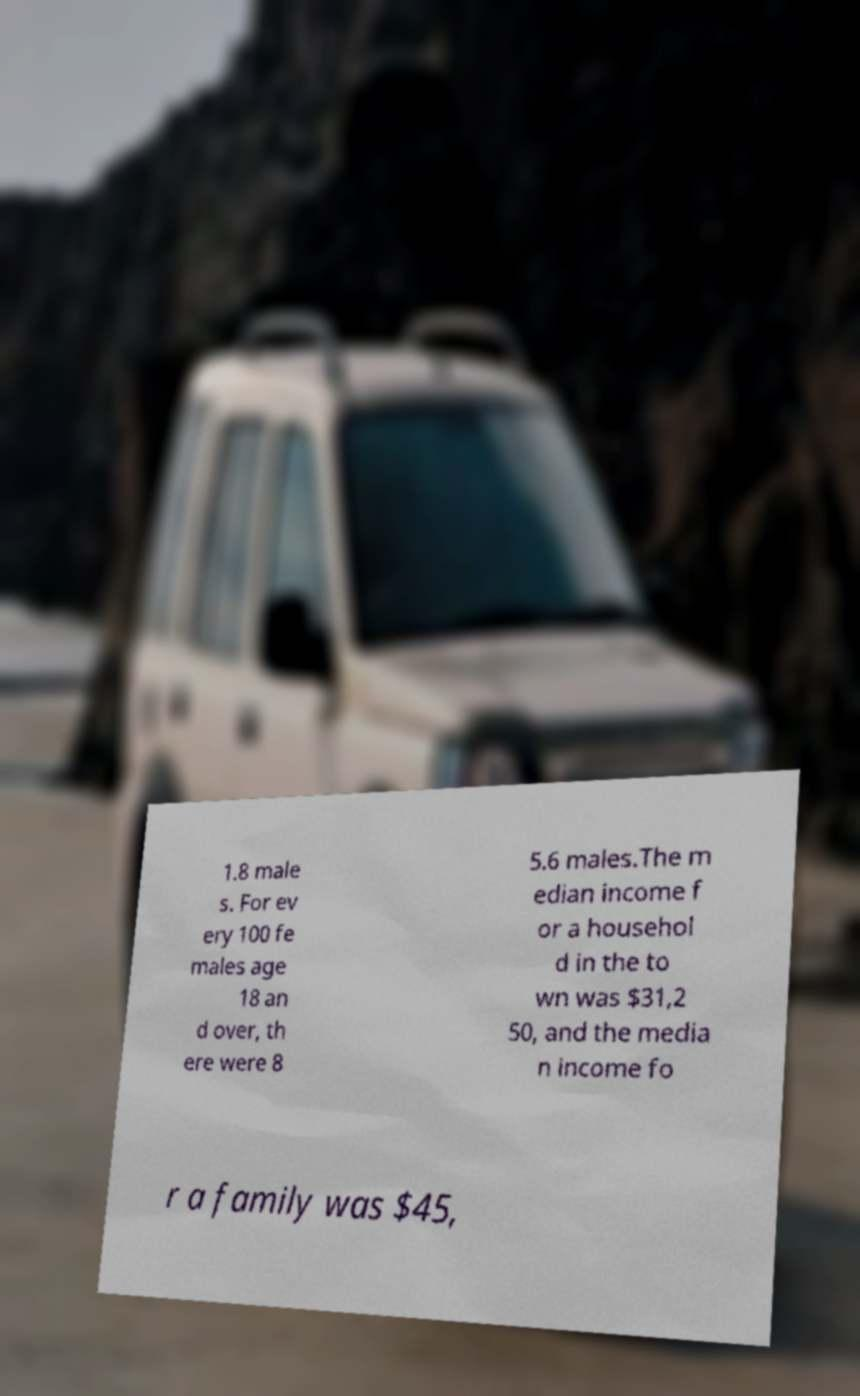There's text embedded in this image that I need extracted. Can you transcribe it verbatim? 1.8 male s. For ev ery 100 fe males age 18 an d over, th ere were 8 5.6 males.The m edian income f or a househol d in the to wn was $31,2 50, and the media n income fo r a family was $45, 